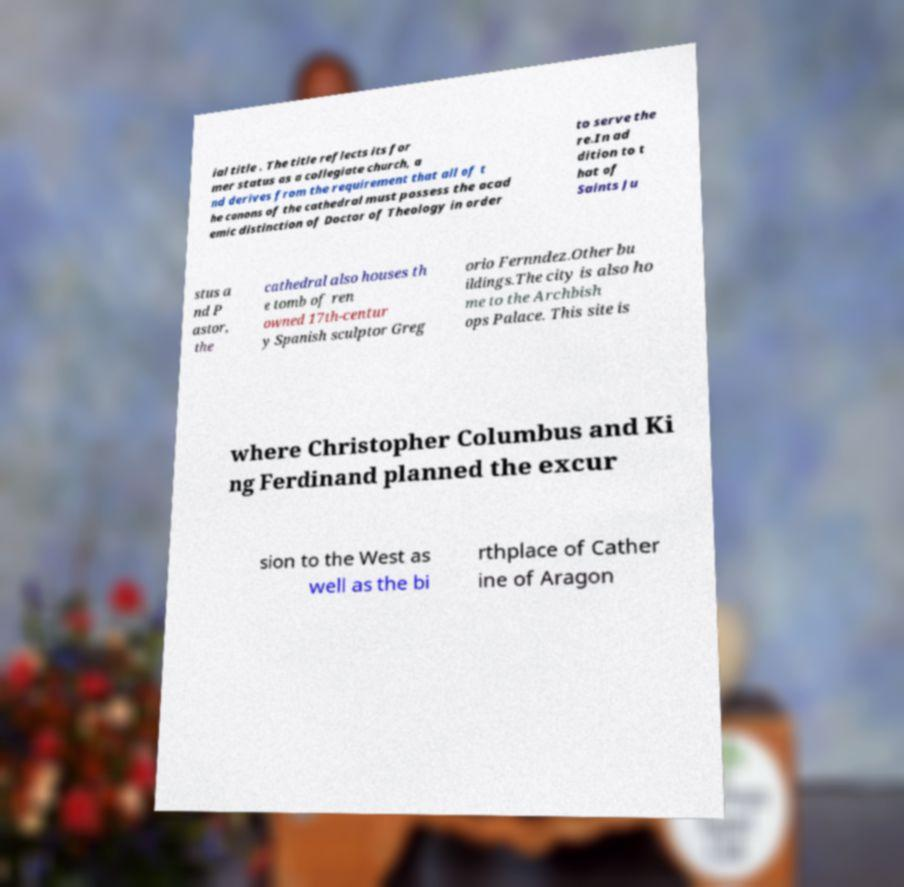What messages or text are displayed in this image? I need them in a readable, typed format. ial title . The title reflects its for mer status as a collegiate church, a nd derives from the requirement that all of t he canons of the cathedral must possess the acad emic distinction of Doctor of Theology in order to serve the re.In ad dition to t hat of Saints Ju stus a nd P astor, the cathedral also houses th e tomb of ren owned 17th-centur y Spanish sculptor Greg orio Fernndez.Other bu ildings.The city is also ho me to the Archbish ops Palace. This site is where Christopher Columbus and Ki ng Ferdinand planned the excur sion to the West as well as the bi rthplace of Cather ine of Aragon 